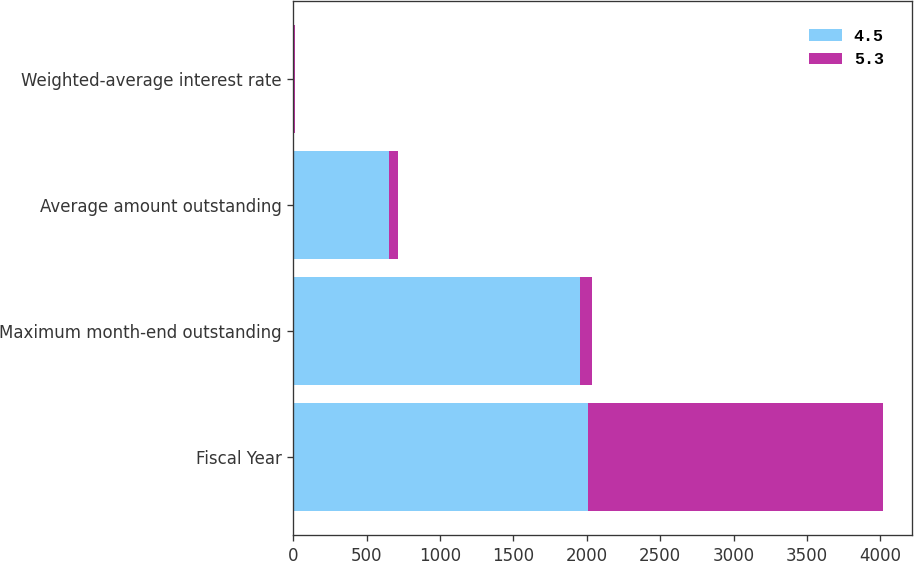Convert chart to OTSL. <chart><loc_0><loc_0><loc_500><loc_500><stacked_bar_chart><ecel><fcel>Fiscal Year<fcel>Maximum month-end outstanding<fcel>Average amount outstanding<fcel>Weighted-average interest rate<nl><fcel>4.5<fcel>2008<fcel>1955<fcel>655<fcel>4.5<nl><fcel>5.3<fcel>2007<fcel>78<fcel>57<fcel>5.3<nl></chart> 